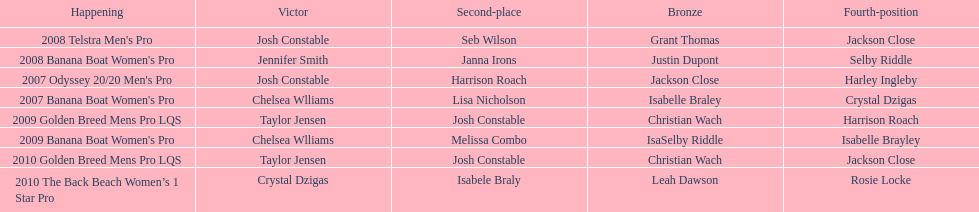After 2007, how many occasions did josh constable claim victory? 1. 